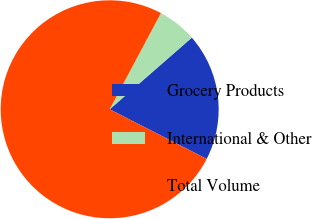Convert chart to OTSL. <chart><loc_0><loc_0><loc_500><loc_500><pie_chart><fcel>Grocery Products<fcel>International & Other<fcel>Total Volume<nl><fcel>18.95%<fcel>5.79%<fcel>75.26%<nl></chart> 